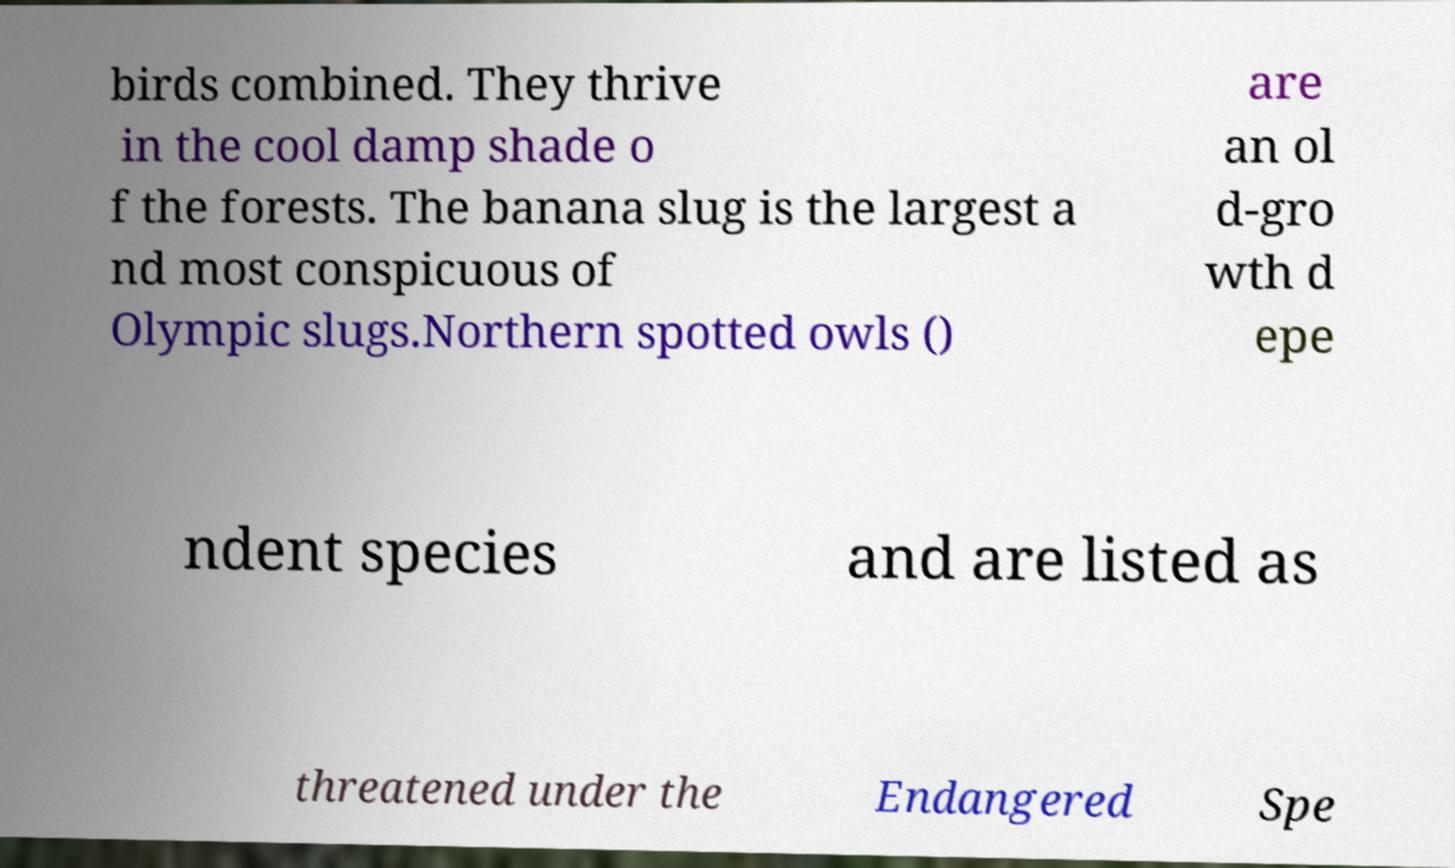Could you assist in decoding the text presented in this image and type it out clearly? birds combined. They thrive in the cool damp shade o f the forests. The banana slug is the largest a nd most conspicuous of Olympic slugs.Northern spotted owls () are an ol d-gro wth d epe ndent species and are listed as threatened under the Endangered Spe 